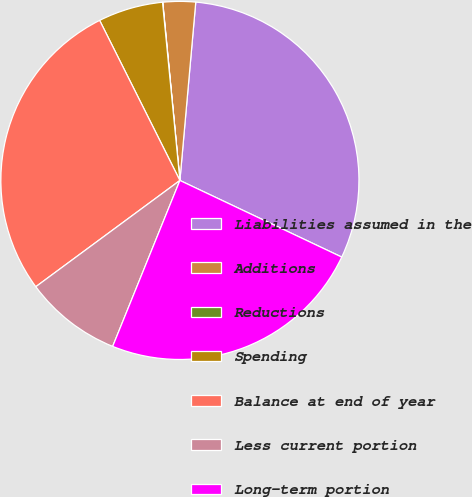Convert chart to OTSL. <chart><loc_0><loc_0><loc_500><loc_500><pie_chart><fcel>Liabilities assumed in the<fcel>Additions<fcel>Reductions<fcel>Spending<fcel>Balance at end of year<fcel>Less current portion<fcel>Long-term portion<nl><fcel>30.63%<fcel>2.94%<fcel>0.02%<fcel>5.85%<fcel>27.72%<fcel>8.76%<fcel>24.09%<nl></chart> 